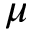Convert formula to latex. <formula><loc_0><loc_0><loc_500><loc_500>\mu</formula> 